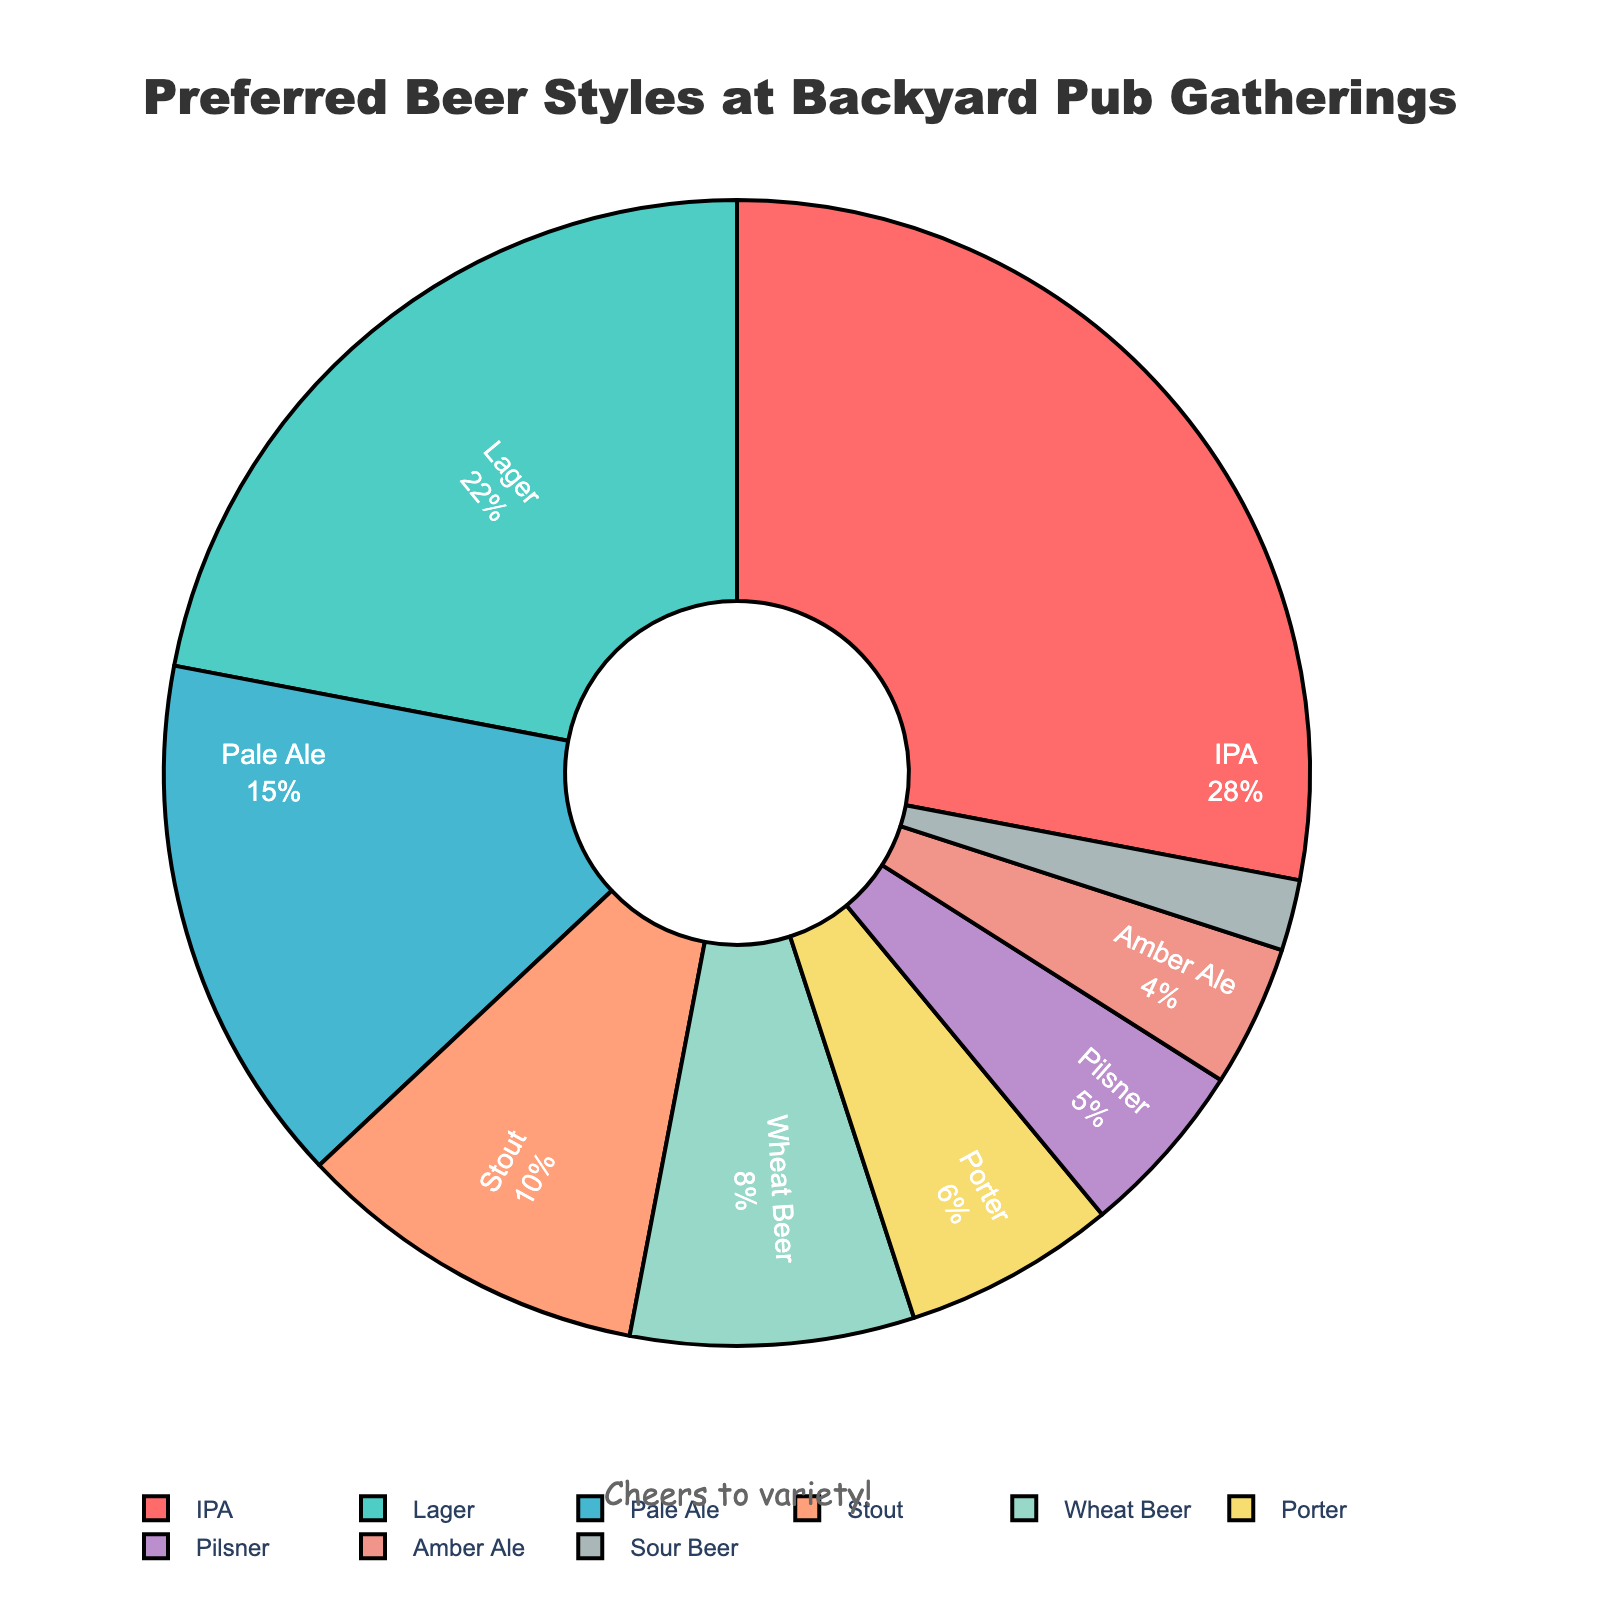Which beer style is the most preferred at backyard pub gatherings? The pie chart shows that IPA has the largest segment and is labeled with a percentage of 28%. Hence, IPA is the most preferred beer style.
Answer: IPA Which beer styles together make up more than 50% of the preferences? Adding the percentages of the top beer styles, IPA (28%), Lager (22%), and Pale Ale (15%), these total up to 65%, which is more than 50%.
Answer: IPA, Lager, and Pale Ale What is the combined percentage preference for Sour Beer and Amber Ale? The percentage of Sour Beer is 2% and Amber Ale is 4%. Adding them together gives 6%.
Answer: 6% How does the preference for Stout compare to that for Porter? The percentage for Stout is 10%, and for Porter, it is 6%. Stout has a higher preference percentage than Porter.
Answer: Stout has higher preference What is the difference in preference percentage between the most and least preferred beer styles? The most preferred beer style is IPA with 28%, and the least preferred is Sour Beer with 2%. The difference is 28% - 2% = 26%.
Answer: 26% Which two beer styles have the closest percentages in preference? Comparing the percentages, Pilsner has 5% and Porter has 6%, which have only a 1% difference between them, making them the closest in preferences.
Answer: Porter and Pilsner What percentage of people prefer Stout and Wheat Beer combined? Summing up the percentages for Stout (10%) and Wheat Beer (8%) gives a total of 18%.
Answer: 18% How many beer styles have a preference of less than 10%? Looking at the chart, Wheat Beer (8%), Porter (6%), Pilsner (5%), Amber Ale (4%), and Sour Beer (2%) all have percentages less than 10%. There are 5 such beer styles.
Answer: 5 What percentage of people prefer either Lager or Pale Ale? The percentage for Lager is 22% and for Pale Ale is 15%. Adding these together gives 37%.
Answer: 37% Considering only beers preferred by at least 10% of people, what is their combined percentage? The beers with at least 10% preference are IPA (28%), Lager (22%), Pale Ale (15%), and Stout (10%). Combined, they total 75%.
Answer: 75% 